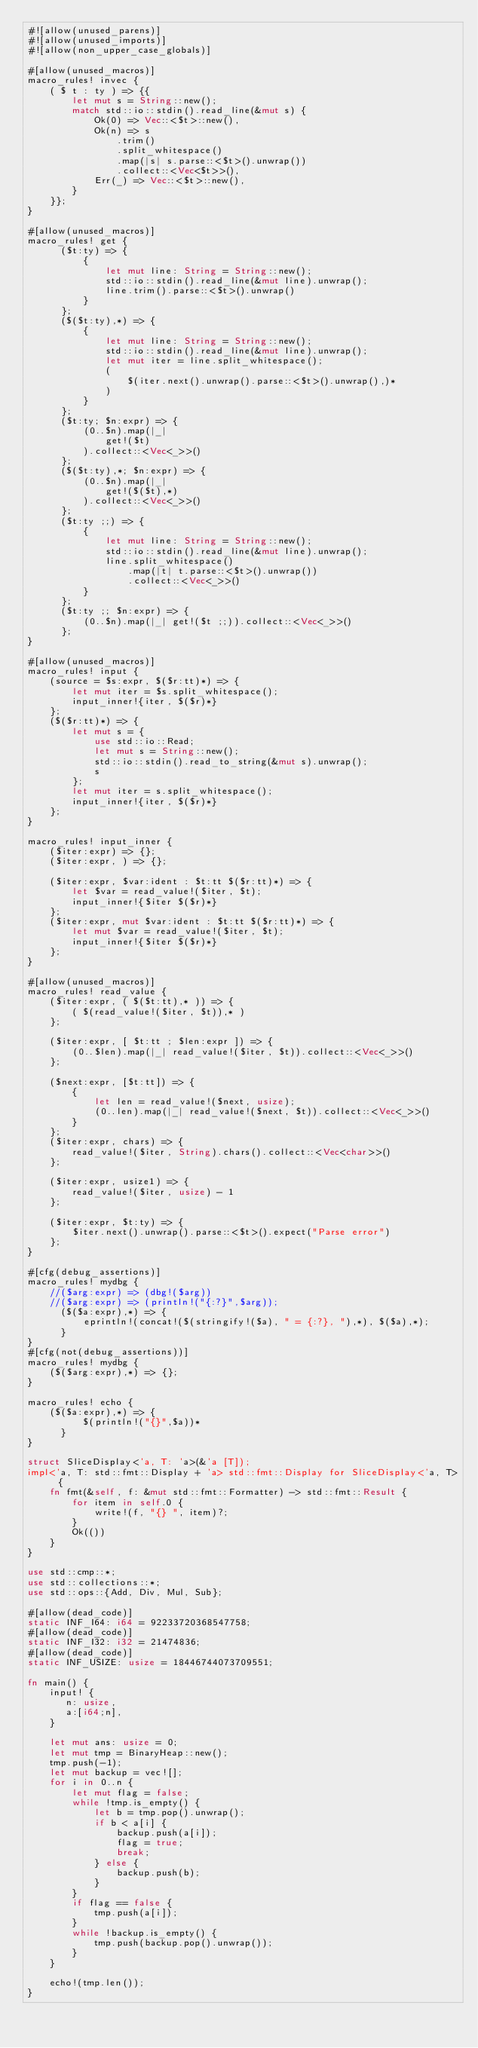Convert code to text. <code><loc_0><loc_0><loc_500><loc_500><_Rust_>#![allow(unused_parens)]
#![allow(unused_imports)]
#![allow(non_upper_case_globals)]

#[allow(unused_macros)]
macro_rules! invec {
    ( $ t : ty ) => {{
        let mut s = String::new();
        match std::io::stdin().read_line(&mut s) {
            Ok(0) => Vec::<$t>::new(),
            Ok(n) => s
                .trim()
                .split_whitespace()
                .map(|s| s.parse::<$t>().unwrap())
                .collect::<Vec<$t>>(),
            Err(_) => Vec::<$t>::new(),
        }
    }};
}

#[allow(unused_macros)]
macro_rules! get {
      ($t:ty) => {
          {
              let mut line: String = String::new();
              std::io::stdin().read_line(&mut line).unwrap();
              line.trim().parse::<$t>().unwrap()
          }
      };
      ($($t:ty),*) => {
          {
              let mut line: String = String::new();
              std::io::stdin().read_line(&mut line).unwrap();
              let mut iter = line.split_whitespace();
              (
                  $(iter.next().unwrap().parse::<$t>().unwrap(),)*
              )
          }
      };
      ($t:ty; $n:expr) => {
          (0..$n).map(|_|
              get!($t)
          ).collect::<Vec<_>>()
      };
      ($($t:ty),*; $n:expr) => {
          (0..$n).map(|_|
              get!($($t),*)
          ).collect::<Vec<_>>()
      };
      ($t:ty ;;) => {
          {
              let mut line: String = String::new();
              std::io::stdin().read_line(&mut line).unwrap();
              line.split_whitespace()
                  .map(|t| t.parse::<$t>().unwrap())
                  .collect::<Vec<_>>()
          }
      };
      ($t:ty ;; $n:expr) => {
          (0..$n).map(|_| get!($t ;;)).collect::<Vec<_>>()
      };
}

#[allow(unused_macros)]
macro_rules! input {
    (source = $s:expr, $($r:tt)*) => {
        let mut iter = $s.split_whitespace();
        input_inner!{iter, $($r)*}
    };
    ($($r:tt)*) => {
        let mut s = {
            use std::io::Read;
            let mut s = String::new();
            std::io::stdin().read_to_string(&mut s).unwrap();
            s
        };
        let mut iter = s.split_whitespace();
        input_inner!{iter, $($r)*}
    };
}

macro_rules! input_inner {
    ($iter:expr) => {};
    ($iter:expr, ) => {};

    ($iter:expr, $var:ident : $t:tt $($r:tt)*) => {
        let $var = read_value!($iter, $t);
        input_inner!{$iter $($r)*}
    };
    ($iter:expr, mut $var:ident : $t:tt $($r:tt)*) => {
        let mut $var = read_value!($iter, $t);
        input_inner!{$iter $($r)*}
    };
}

#[allow(unused_macros)]
macro_rules! read_value {
    ($iter:expr, ( $($t:tt),* )) => {
        ( $(read_value!($iter, $t)),* )
    };

    ($iter:expr, [ $t:tt ; $len:expr ]) => {
        (0..$len).map(|_| read_value!($iter, $t)).collect::<Vec<_>>()
    };

    ($next:expr, [$t:tt]) => {
        {
            let len = read_value!($next, usize);
            (0..len).map(|_| read_value!($next, $t)).collect::<Vec<_>>()
        }
    };
    ($iter:expr, chars) => {
        read_value!($iter, String).chars().collect::<Vec<char>>()
    };

    ($iter:expr, usize1) => {
        read_value!($iter, usize) - 1
    };

    ($iter:expr, $t:ty) => {
        $iter.next().unwrap().parse::<$t>().expect("Parse error")
    };
}

#[cfg(debug_assertions)]
macro_rules! mydbg {
    //($arg:expr) => (dbg!($arg))
    //($arg:expr) => (println!("{:?}",$arg));
      ($($a:expr),*) => {
          eprintln!(concat!($(stringify!($a), " = {:?}, "),*), $($a),*);
      }
}
#[cfg(not(debug_assertions))]
macro_rules! mydbg {
    ($($arg:expr),*) => {};
}

macro_rules! echo {
    ($($a:expr),*) => {
          $(println!("{}",$a))*
      }
}

struct SliceDisplay<'a, T: 'a>(&'a [T]);
impl<'a, T: std::fmt::Display + 'a> std::fmt::Display for SliceDisplay<'a, T> {
    fn fmt(&self, f: &mut std::fmt::Formatter) -> std::fmt::Result {
        for item in self.0 {
            write!(f, "{} ", item)?;
        }
        Ok(())
    }
}

use std::cmp::*;
use std::collections::*;
use std::ops::{Add, Div, Mul, Sub};

#[allow(dead_code)]
static INF_I64: i64 = 92233720368547758;
#[allow(dead_code)]
static INF_I32: i32 = 21474836;
#[allow(dead_code)]
static INF_USIZE: usize = 18446744073709551;

fn main() {
    input! {
       n: usize,
       a:[i64;n],
    }

    let mut ans: usize = 0;
    let mut tmp = BinaryHeap::new();
    tmp.push(-1);
    let mut backup = vec![];
    for i in 0..n {
        let mut flag = false;
        while !tmp.is_empty() {
            let b = tmp.pop().unwrap();
            if b < a[i] {
                backup.push(a[i]);
                flag = true;
                break;
            } else {
                backup.push(b);
            }
        }
        if flag == false {
            tmp.push(a[i]);
        }
        while !backup.is_empty() {
            tmp.push(backup.pop().unwrap());
        }
    }

    echo!(tmp.len());
}
</code> 